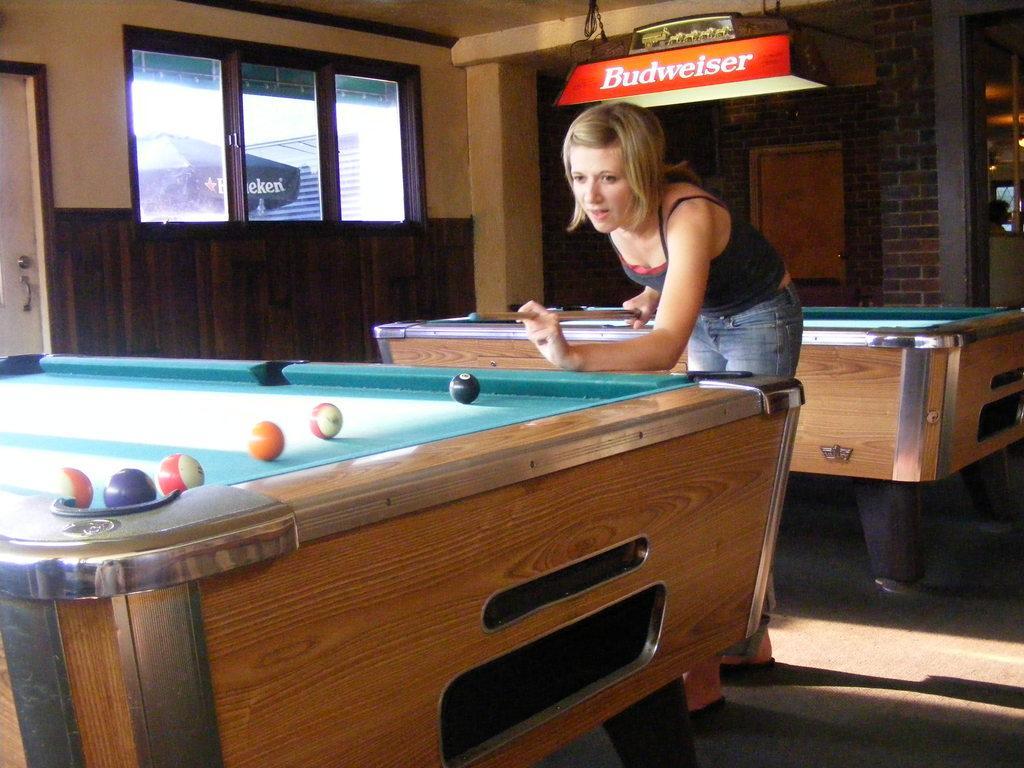How would you summarize this image in a sentence or two? There is a woman holding a stick in her hand and playing 8 ball pool. 